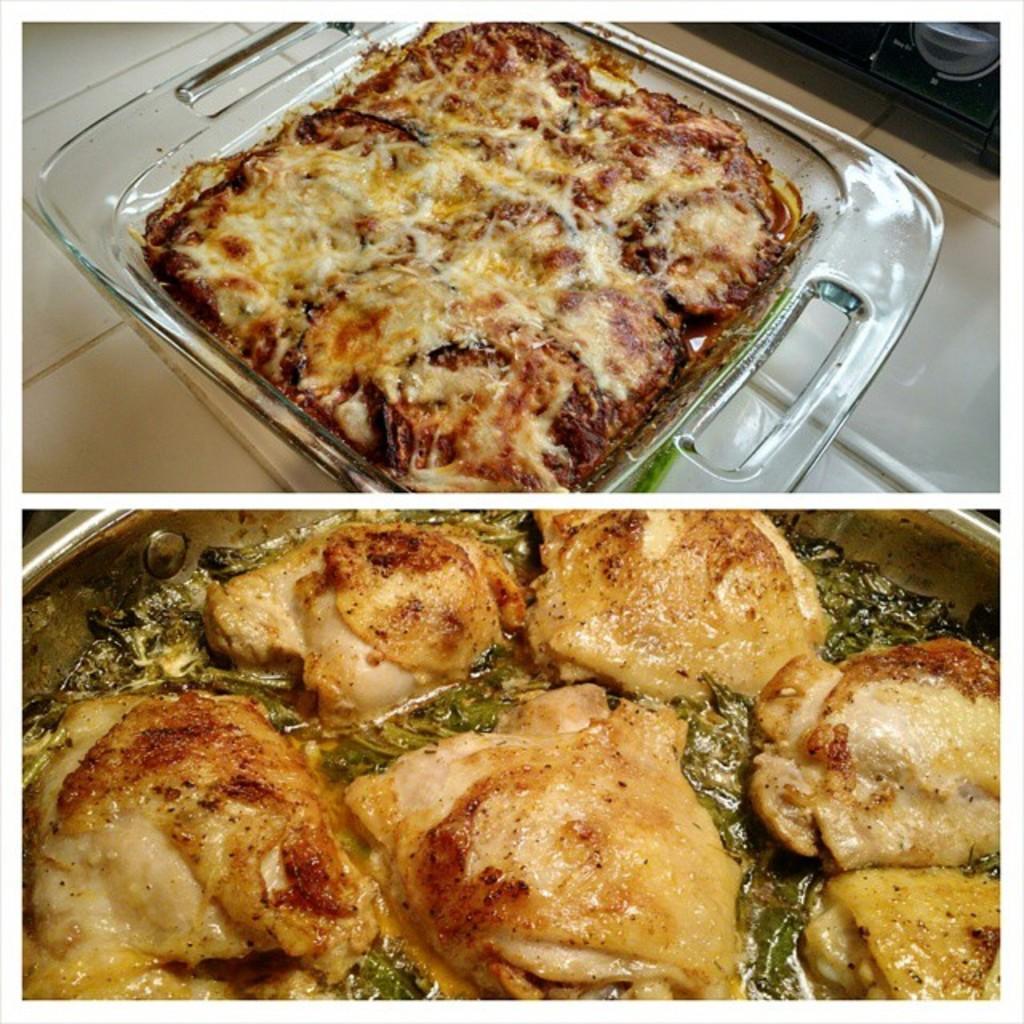Could you give a brief overview of what you see in this image? In this image I can see it is a photo collage, there are food items. 